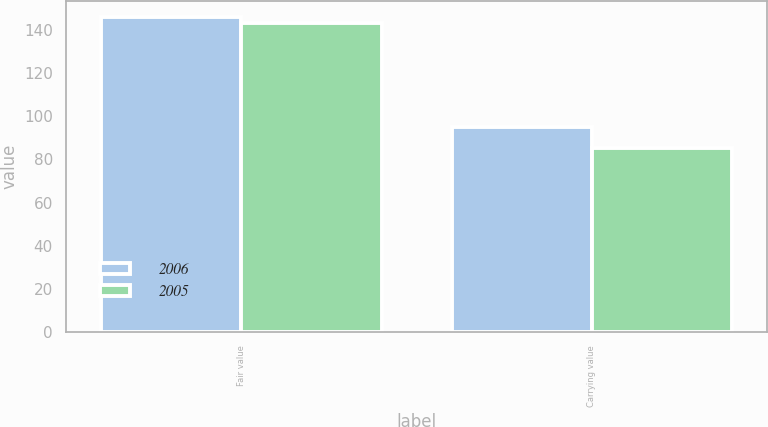Convert chart. <chart><loc_0><loc_0><loc_500><loc_500><stacked_bar_chart><ecel><fcel>Fair value<fcel>Carrying value<nl><fcel>2006<fcel>146<fcel>95<nl><fcel>2005<fcel>143<fcel>85<nl></chart> 